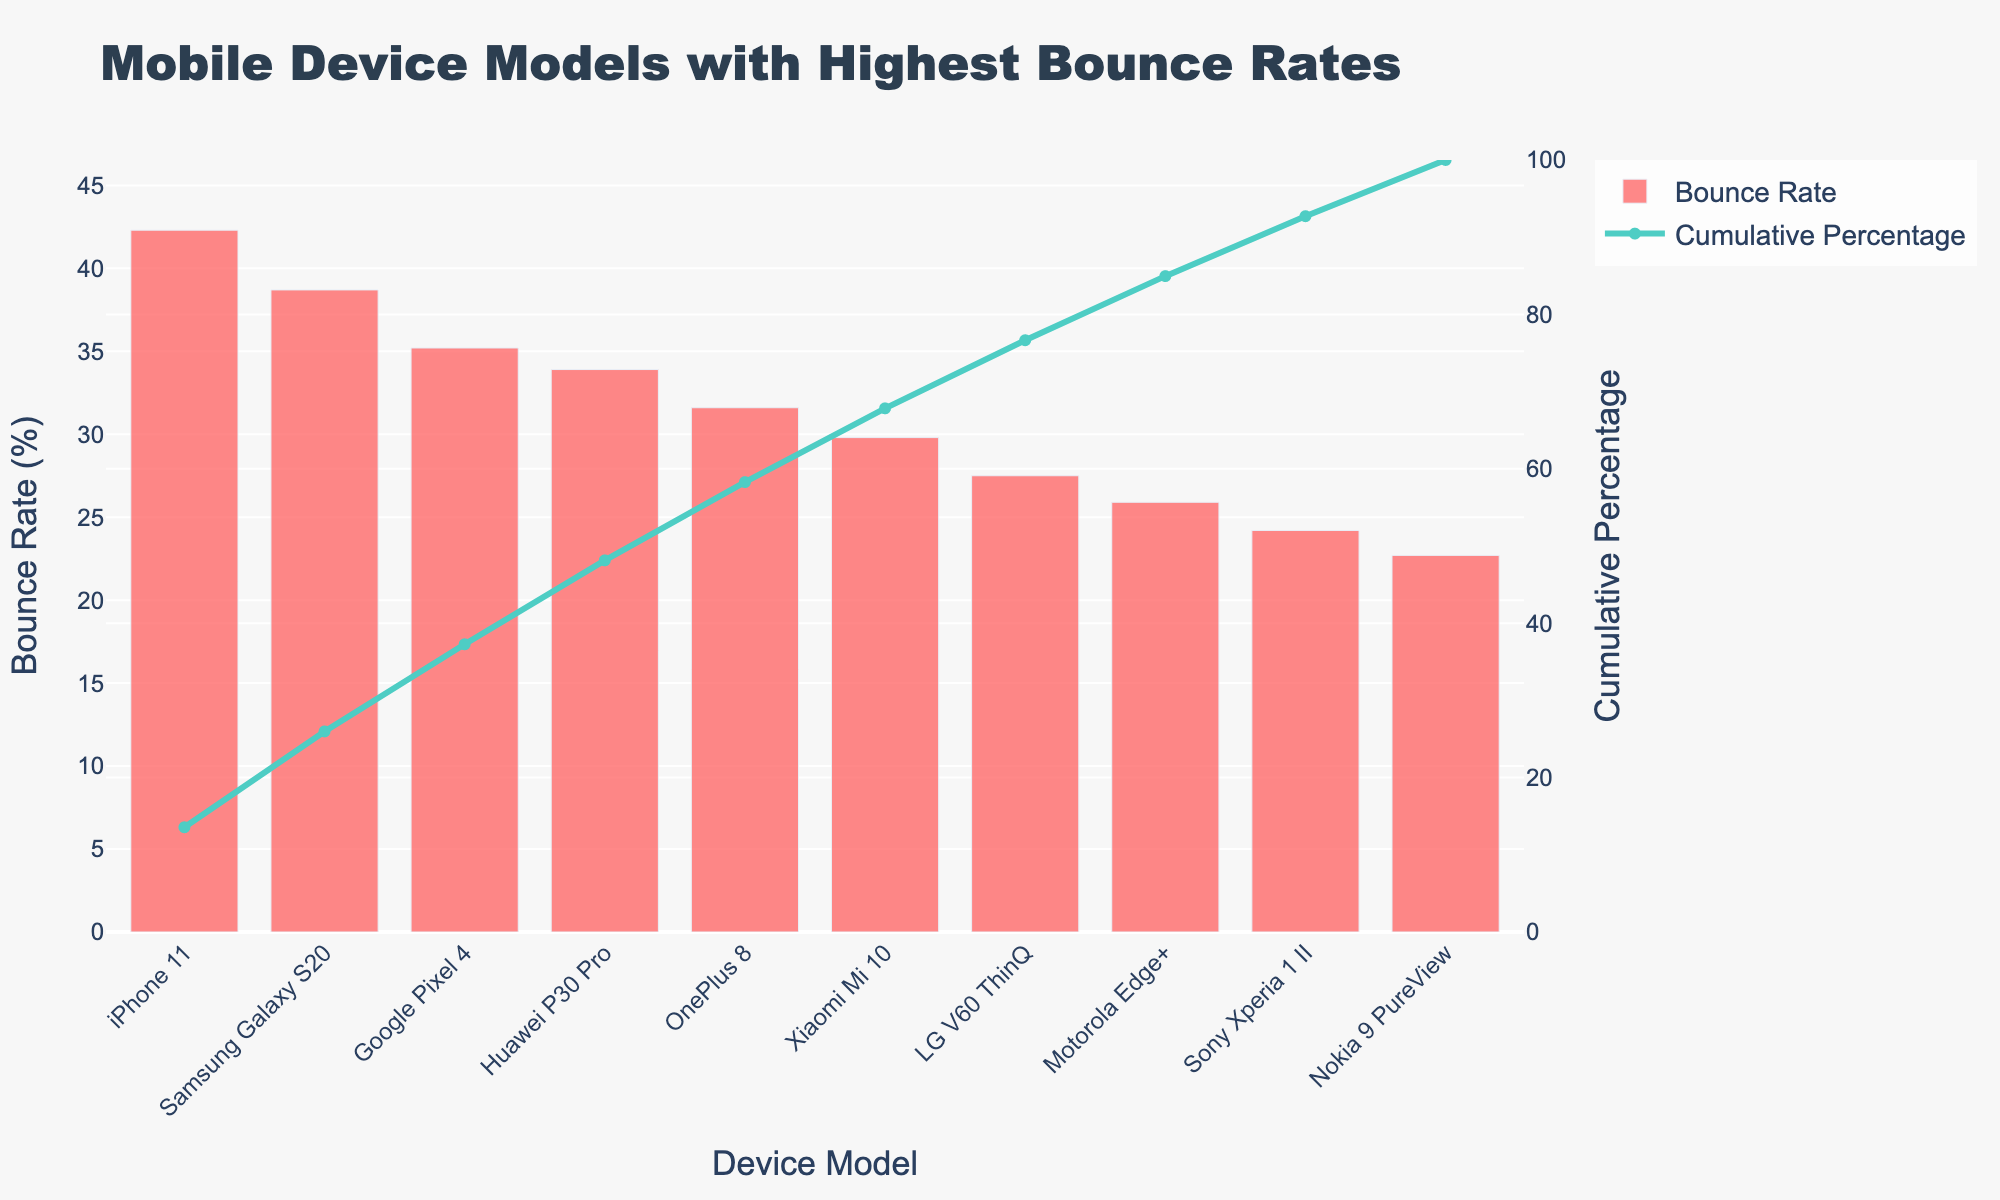What's the title of the figure? The title of the figure is displayed prominently at the top and describes the main insight the chart is communicating.
Answer: Mobile Device Models with Highest Bounce Rates Which device model has the highest bounce rate? The highest bar in the bar chart represents the device model with the highest bounce rate.
Answer: iPhone 11 What is the bounce rate of the Samsung Galaxy S20? The bar corresponding to the Samsung Galaxy S20 shows its bounce rate as a percentage.
Answer: 38.7% How many device models are represented in the chart? Counting the number of bars in the bar chart correlates to the number of device models listed.
Answer: 10 What's the cumulative percentage of bounce rate for the top three device models? Add the cumulative percentages shown on the line chart for the top three device models. The top three cumulative percentages are (42.3%, 81.0%, and 116.2%).
Answer: 81.0% Which device model has the lowest bounce rate? The smallest bar in the bar chart corresponds to the device model with the lowest bounce rate.
Answer: Nokia 9 PureView What's the cumulative percentage of bounce rate for the iPhone 11? The line chart shows the cumulative percentage at the top of its corresponding bar. Look at the cumulative percentage value above the iPhone 11 bar.
Answer: 42.3% Compare the bounce rates of the Google Pixel 4 and the Huawei P30 Pro. Which one is higher? Examine the heights of the bars corresponding to the Google Pixel 4 and Huawei P30 Pro, and compare them.
Answer: Google Pixel 4 Which device model reaches a cumulative percentage of approximately 100%? Review the line chart and identify the device model where the cumulative percentage line reaches or crosses the 100% mark.
Answer: OnePlus 8 What are the bounce rates for the Motorola Edge+ and the Sony Xperia 1 II? Read the values of the bars represented for Motorola Edge+ and Sony Xperia 1 II in the bar chart.
Answer: Motorola Edge+: 25.9%, Sony Xperia 1 II: 24.2% 